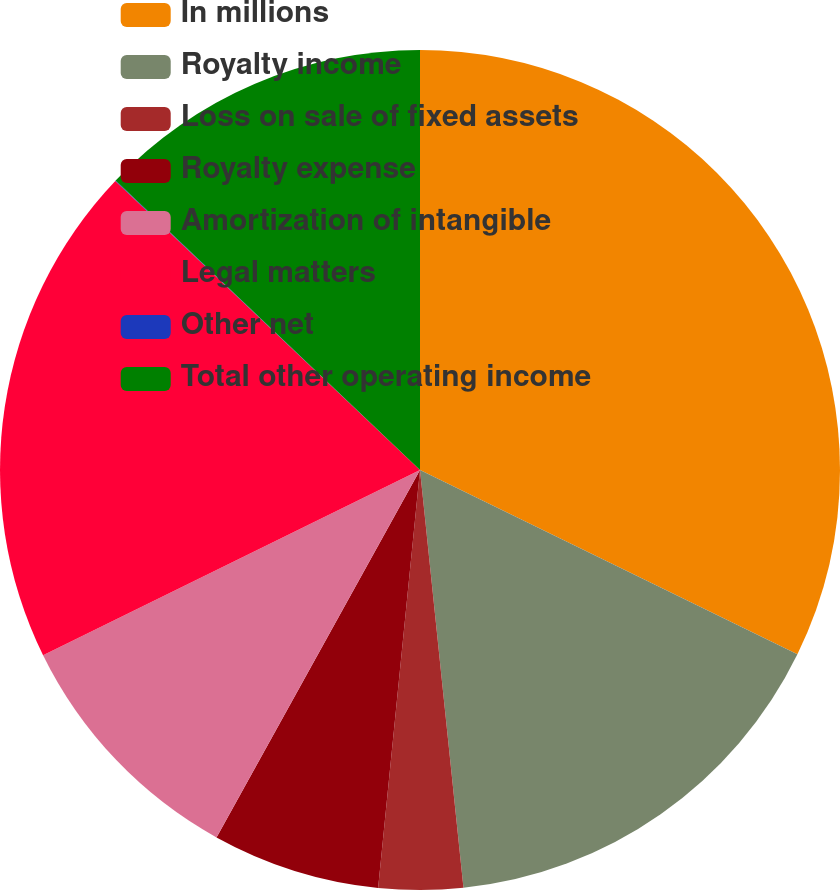<chart> <loc_0><loc_0><loc_500><loc_500><pie_chart><fcel>In millions<fcel>Royalty income<fcel>Loss on sale of fixed assets<fcel>Royalty expense<fcel>Amortization of intangible<fcel>Legal matters<fcel>Other net<fcel>Total other operating income<nl><fcel>32.23%<fcel>16.12%<fcel>3.24%<fcel>6.46%<fcel>9.68%<fcel>19.35%<fcel>0.02%<fcel>12.9%<nl></chart> 